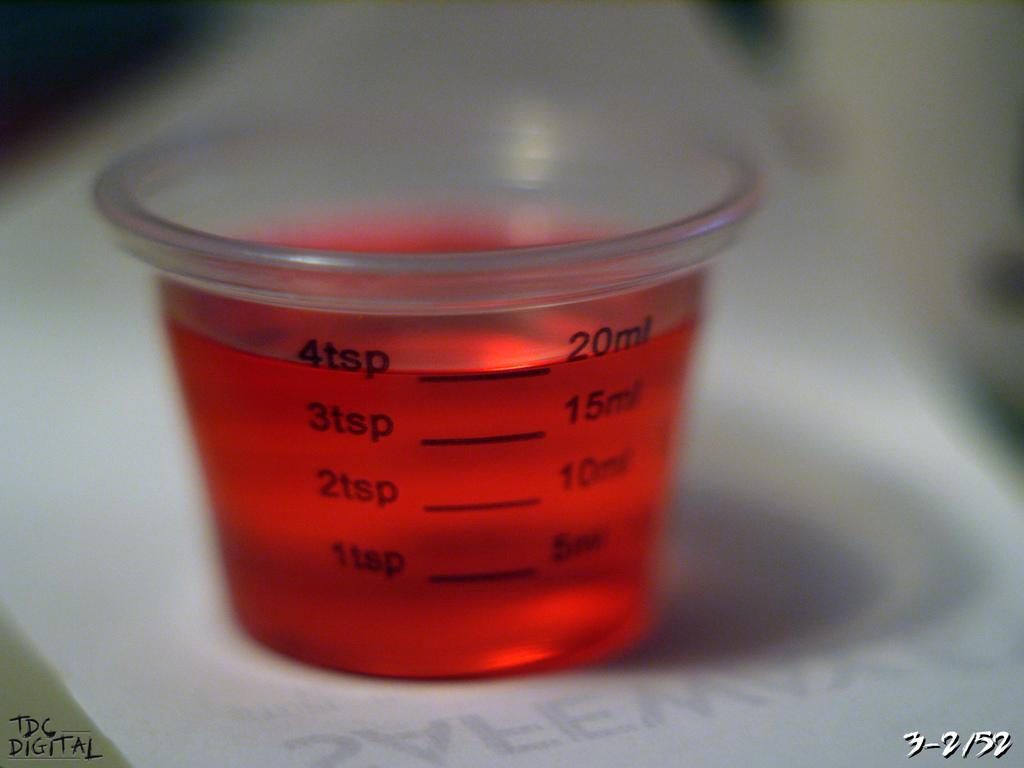<image>
Render a clear and concise summary of the photo. A small medicine cup with 4 tsp of red liquid in it. 